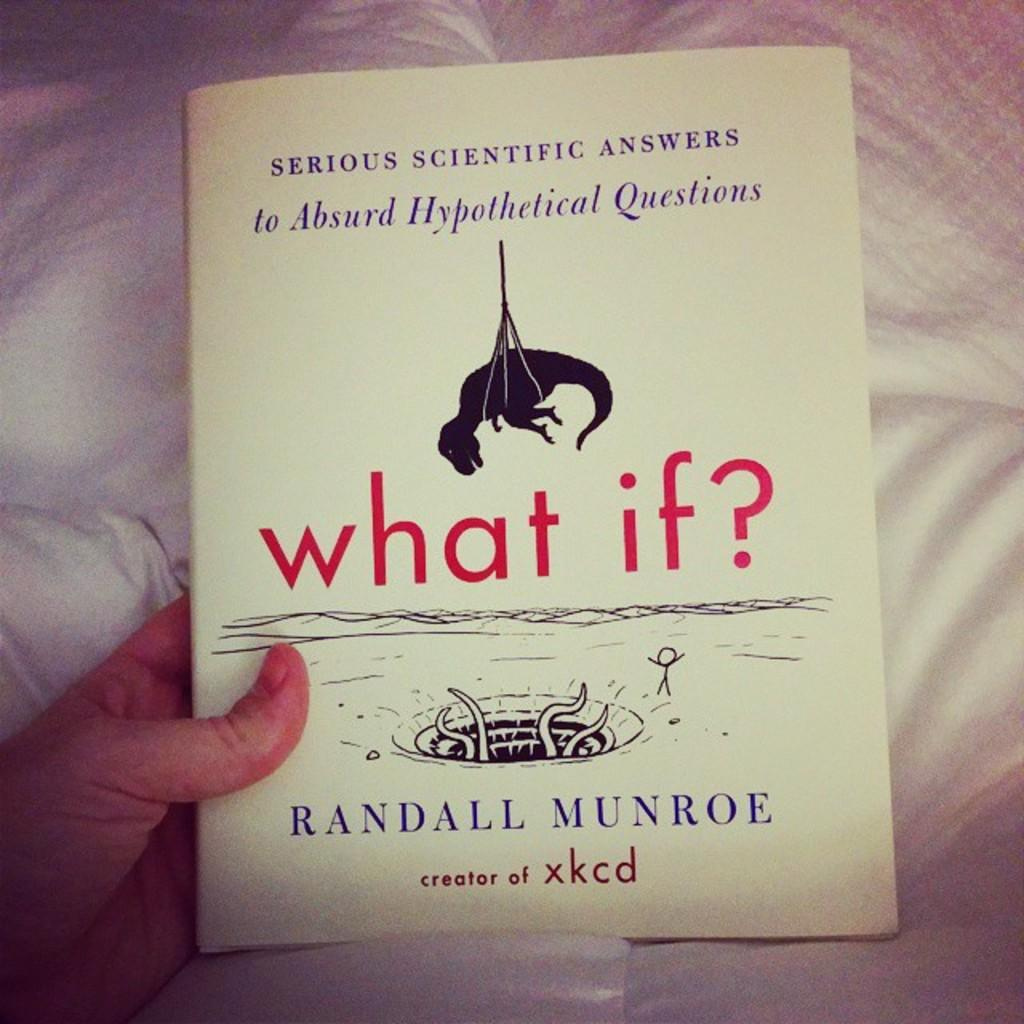<image>
Present a compact description of the photo's key features. A man holding a book titled What If? by Randall Munroe. 